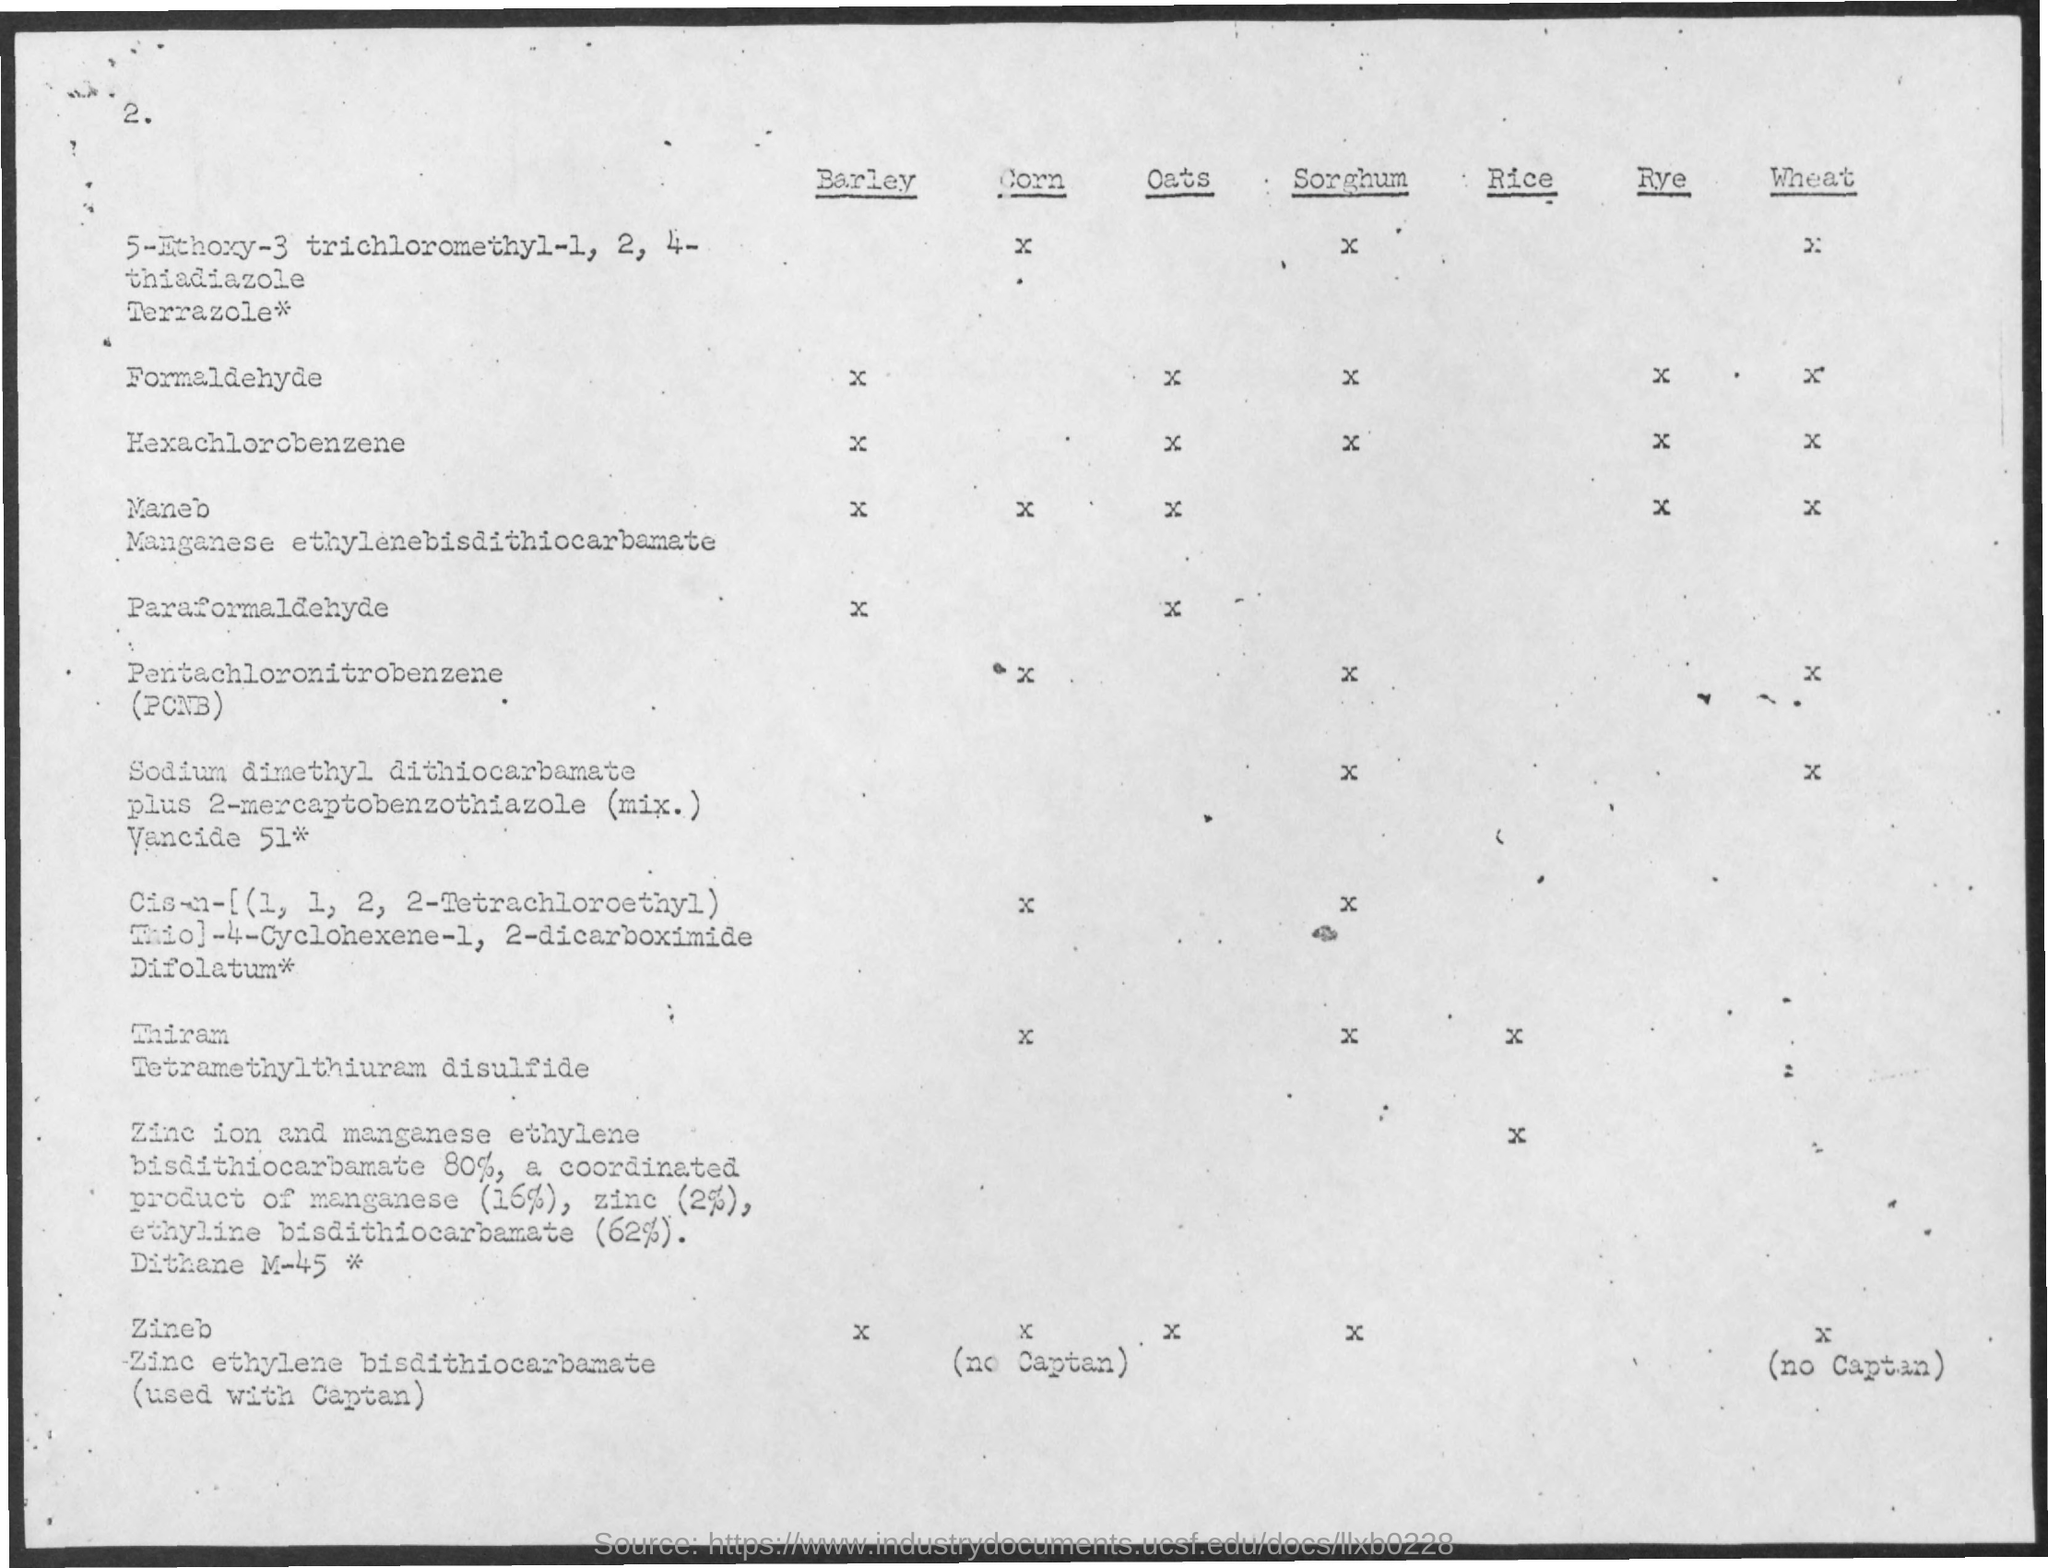Indicate a few pertinent items in this graphic. The page number is two... 